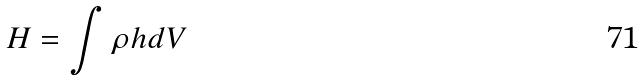Convert formula to latex. <formula><loc_0><loc_0><loc_500><loc_500>H = \int \rho h d V</formula> 